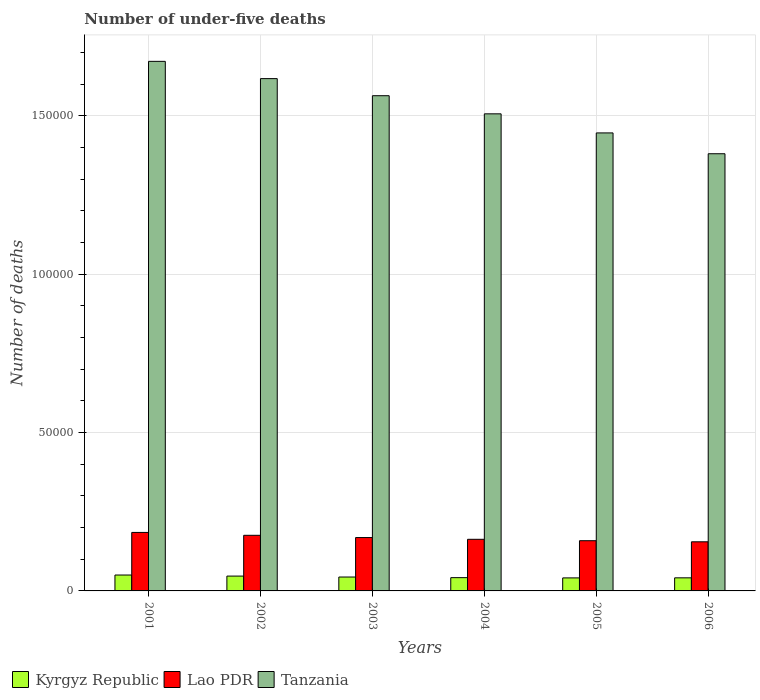How many different coloured bars are there?
Offer a very short reply. 3. Are the number of bars per tick equal to the number of legend labels?
Ensure brevity in your answer.  Yes. Are the number of bars on each tick of the X-axis equal?
Keep it short and to the point. Yes. How many bars are there on the 5th tick from the left?
Keep it short and to the point. 3. What is the number of under-five deaths in Kyrgyz Republic in 2001?
Provide a short and direct response. 5021. Across all years, what is the maximum number of under-five deaths in Tanzania?
Your response must be concise. 1.67e+05. Across all years, what is the minimum number of under-five deaths in Tanzania?
Give a very brief answer. 1.38e+05. In which year was the number of under-five deaths in Lao PDR maximum?
Provide a succinct answer. 2001. In which year was the number of under-five deaths in Tanzania minimum?
Keep it short and to the point. 2006. What is the total number of under-five deaths in Kyrgyz Republic in the graph?
Your response must be concise. 2.65e+04. What is the difference between the number of under-five deaths in Kyrgyz Republic in 2001 and that in 2002?
Your answer should be very brief. 336. What is the difference between the number of under-five deaths in Kyrgyz Republic in 2003 and the number of under-five deaths in Lao PDR in 2004?
Provide a succinct answer. -1.19e+04. What is the average number of under-five deaths in Kyrgyz Republic per year?
Make the answer very short. 4421.5. In the year 2002, what is the difference between the number of under-five deaths in Tanzania and number of under-five deaths in Kyrgyz Republic?
Your answer should be very brief. 1.57e+05. What is the ratio of the number of under-five deaths in Tanzania in 2001 to that in 2006?
Your answer should be compact. 1.21. Is the difference between the number of under-five deaths in Tanzania in 2005 and 2006 greater than the difference between the number of under-five deaths in Kyrgyz Republic in 2005 and 2006?
Keep it short and to the point. Yes. What is the difference between the highest and the second highest number of under-five deaths in Kyrgyz Republic?
Ensure brevity in your answer.  336. What is the difference between the highest and the lowest number of under-five deaths in Lao PDR?
Offer a very short reply. 2957. What does the 1st bar from the left in 2003 represents?
Make the answer very short. Kyrgyz Republic. What does the 2nd bar from the right in 2002 represents?
Offer a terse response. Lao PDR. Is it the case that in every year, the sum of the number of under-five deaths in Lao PDR and number of under-five deaths in Kyrgyz Republic is greater than the number of under-five deaths in Tanzania?
Your answer should be compact. No. How many bars are there?
Keep it short and to the point. 18. Are all the bars in the graph horizontal?
Make the answer very short. No. What is the difference between two consecutive major ticks on the Y-axis?
Give a very brief answer. 5.00e+04. Are the values on the major ticks of Y-axis written in scientific E-notation?
Provide a succinct answer. No. Does the graph contain grids?
Keep it short and to the point. Yes. Where does the legend appear in the graph?
Give a very brief answer. Bottom left. What is the title of the graph?
Provide a short and direct response. Number of under-five deaths. What is the label or title of the X-axis?
Your answer should be very brief. Years. What is the label or title of the Y-axis?
Ensure brevity in your answer.  Number of deaths. What is the Number of deaths in Kyrgyz Republic in 2001?
Make the answer very short. 5021. What is the Number of deaths of Lao PDR in 2001?
Make the answer very short. 1.85e+04. What is the Number of deaths in Tanzania in 2001?
Provide a succinct answer. 1.67e+05. What is the Number of deaths in Kyrgyz Republic in 2002?
Provide a short and direct response. 4685. What is the Number of deaths of Lao PDR in 2002?
Your answer should be very brief. 1.76e+04. What is the Number of deaths in Tanzania in 2002?
Your answer should be compact. 1.62e+05. What is the Number of deaths in Kyrgyz Republic in 2003?
Keep it short and to the point. 4389. What is the Number of deaths in Lao PDR in 2003?
Provide a short and direct response. 1.68e+04. What is the Number of deaths of Tanzania in 2003?
Make the answer very short. 1.56e+05. What is the Number of deaths in Kyrgyz Republic in 2004?
Your answer should be compact. 4189. What is the Number of deaths in Lao PDR in 2004?
Give a very brief answer. 1.63e+04. What is the Number of deaths in Tanzania in 2004?
Make the answer very short. 1.51e+05. What is the Number of deaths of Kyrgyz Republic in 2005?
Keep it short and to the point. 4113. What is the Number of deaths in Lao PDR in 2005?
Keep it short and to the point. 1.59e+04. What is the Number of deaths of Tanzania in 2005?
Ensure brevity in your answer.  1.45e+05. What is the Number of deaths in Kyrgyz Republic in 2006?
Offer a very short reply. 4132. What is the Number of deaths in Lao PDR in 2006?
Your answer should be compact. 1.55e+04. What is the Number of deaths of Tanzania in 2006?
Your answer should be very brief. 1.38e+05. Across all years, what is the maximum Number of deaths in Kyrgyz Republic?
Your response must be concise. 5021. Across all years, what is the maximum Number of deaths of Lao PDR?
Provide a succinct answer. 1.85e+04. Across all years, what is the maximum Number of deaths in Tanzania?
Your answer should be compact. 1.67e+05. Across all years, what is the minimum Number of deaths of Kyrgyz Republic?
Your answer should be compact. 4113. Across all years, what is the minimum Number of deaths of Lao PDR?
Keep it short and to the point. 1.55e+04. Across all years, what is the minimum Number of deaths of Tanzania?
Offer a terse response. 1.38e+05. What is the total Number of deaths of Kyrgyz Republic in the graph?
Your answer should be compact. 2.65e+04. What is the total Number of deaths of Lao PDR in the graph?
Keep it short and to the point. 1.01e+05. What is the total Number of deaths in Tanzania in the graph?
Provide a short and direct response. 9.19e+05. What is the difference between the Number of deaths in Kyrgyz Republic in 2001 and that in 2002?
Offer a terse response. 336. What is the difference between the Number of deaths of Lao PDR in 2001 and that in 2002?
Your answer should be compact. 907. What is the difference between the Number of deaths in Tanzania in 2001 and that in 2002?
Your answer should be compact. 5450. What is the difference between the Number of deaths in Kyrgyz Republic in 2001 and that in 2003?
Offer a terse response. 632. What is the difference between the Number of deaths in Lao PDR in 2001 and that in 2003?
Your answer should be very brief. 1617. What is the difference between the Number of deaths in Tanzania in 2001 and that in 2003?
Keep it short and to the point. 1.08e+04. What is the difference between the Number of deaths in Kyrgyz Republic in 2001 and that in 2004?
Keep it short and to the point. 832. What is the difference between the Number of deaths in Lao PDR in 2001 and that in 2004?
Your answer should be compact. 2172. What is the difference between the Number of deaths of Tanzania in 2001 and that in 2004?
Give a very brief answer. 1.66e+04. What is the difference between the Number of deaths of Kyrgyz Republic in 2001 and that in 2005?
Your response must be concise. 908. What is the difference between the Number of deaths in Lao PDR in 2001 and that in 2005?
Your answer should be compact. 2614. What is the difference between the Number of deaths of Tanzania in 2001 and that in 2005?
Give a very brief answer. 2.26e+04. What is the difference between the Number of deaths of Kyrgyz Republic in 2001 and that in 2006?
Give a very brief answer. 889. What is the difference between the Number of deaths of Lao PDR in 2001 and that in 2006?
Offer a very short reply. 2957. What is the difference between the Number of deaths in Tanzania in 2001 and that in 2006?
Ensure brevity in your answer.  2.92e+04. What is the difference between the Number of deaths in Kyrgyz Republic in 2002 and that in 2003?
Your answer should be compact. 296. What is the difference between the Number of deaths of Lao PDR in 2002 and that in 2003?
Offer a very short reply. 710. What is the difference between the Number of deaths in Tanzania in 2002 and that in 2003?
Offer a very short reply. 5400. What is the difference between the Number of deaths in Kyrgyz Republic in 2002 and that in 2004?
Offer a terse response. 496. What is the difference between the Number of deaths in Lao PDR in 2002 and that in 2004?
Offer a very short reply. 1265. What is the difference between the Number of deaths of Tanzania in 2002 and that in 2004?
Keep it short and to the point. 1.11e+04. What is the difference between the Number of deaths of Kyrgyz Republic in 2002 and that in 2005?
Your answer should be compact. 572. What is the difference between the Number of deaths of Lao PDR in 2002 and that in 2005?
Give a very brief answer. 1707. What is the difference between the Number of deaths in Tanzania in 2002 and that in 2005?
Offer a very short reply. 1.71e+04. What is the difference between the Number of deaths in Kyrgyz Republic in 2002 and that in 2006?
Your answer should be compact. 553. What is the difference between the Number of deaths in Lao PDR in 2002 and that in 2006?
Offer a terse response. 2050. What is the difference between the Number of deaths in Tanzania in 2002 and that in 2006?
Give a very brief answer. 2.37e+04. What is the difference between the Number of deaths in Kyrgyz Republic in 2003 and that in 2004?
Give a very brief answer. 200. What is the difference between the Number of deaths in Lao PDR in 2003 and that in 2004?
Your answer should be compact. 555. What is the difference between the Number of deaths in Tanzania in 2003 and that in 2004?
Offer a terse response. 5721. What is the difference between the Number of deaths in Kyrgyz Republic in 2003 and that in 2005?
Ensure brevity in your answer.  276. What is the difference between the Number of deaths in Lao PDR in 2003 and that in 2005?
Provide a short and direct response. 997. What is the difference between the Number of deaths in Tanzania in 2003 and that in 2005?
Keep it short and to the point. 1.17e+04. What is the difference between the Number of deaths in Kyrgyz Republic in 2003 and that in 2006?
Provide a succinct answer. 257. What is the difference between the Number of deaths in Lao PDR in 2003 and that in 2006?
Offer a terse response. 1340. What is the difference between the Number of deaths in Tanzania in 2003 and that in 2006?
Provide a succinct answer. 1.83e+04. What is the difference between the Number of deaths in Lao PDR in 2004 and that in 2005?
Provide a short and direct response. 442. What is the difference between the Number of deaths in Tanzania in 2004 and that in 2005?
Your response must be concise. 6023. What is the difference between the Number of deaths in Kyrgyz Republic in 2004 and that in 2006?
Your response must be concise. 57. What is the difference between the Number of deaths in Lao PDR in 2004 and that in 2006?
Provide a succinct answer. 785. What is the difference between the Number of deaths in Tanzania in 2004 and that in 2006?
Offer a terse response. 1.26e+04. What is the difference between the Number of deaths in Lao PDR in 2005 and that in 2006?
Provide a succinct answer. 343. What is the difference between the Number of deaths of Tanzania in 2005 and that in 2006?
Make the answer very short. 6576. What is the difference between the Number of deaths of Kyrgyz Republic in 2001 and the Number of deaths of Lao PDR in 2002?
Your answer should be very brief. -1.25e+04. What is the difference between the Number of deaths of Kyrgyz Republic in 2001 and the Number of deaths of Tanzania in 2002?
Provide a succinct answer. -1.57e+05. What is the difference between the Number of deaths of Lao PDR in 2001 and the Number of deaths of Tanzania in 2002?
Give a very brief answer. -1.43e+05. What is the difference between the Number of deaths in Kyrgyz Republic in 2001 and the Number of deaths in Lao PDR in 2003?
Ensure brevity in your answer.  -1.18e+04. What is the difference between the Number of deaths in Kyrgyz Republic in 2001 and the Number of deaths in Tanzania in 2003?
Provide a succinct answer. -1.51e+05. What is the difference between the Number of deaths of Lao PDR in 2001 and the Number of deaths of Tanzania in 2003?
Your answer should be very brief. -1.38e+05. What is the difference between the Number of deaths in Kyrgyz Republic in 2001 and the Number of deaths in Lao PDR in 2004?
Make the answer very short. -1.13e+04. What is the difference between the Number of deaths of Kyrgyz Republic in 2001 and the Number of deaths of Tanzania in 2004?
Ensure brevity in your answer.  -1.46e+05. What is the difference between the Number of deaths in Lao PDR in 2001 and the Number of deaths in Tanzania in 2004?
Ensure brevity in your answer.  -1.32e+05. What is the difference between the Number of deaths of Kyrgyz Republic in 2001 and the Number of deaths of Lao PDR in 2005?
Provide a short and direct response. -1.08e+04. What is the difference between the Number of deaths of Kyrgyz Republic in 2001 and the Number of deaths of Tanzania in 2005?
Your response must be concise. -1.40e+05. What is the difference between the Number of deaths in Lao PDR in 2001 and the Number of deaths in Tanzania in 2005?
Offer a very short reply. -1.26e+05. What is the difference between the Number of deaths of Kyrgyz Republic in 2001 and the Number of deaths of Lao PDR in 2006?
Your response must be concise. -1.05e+04. What is the difference between the Number of deaths of Kyrgyz Republic in 2001 and the Number of deaths of Tanzania in 2006?
Your response must be concise. -1.33e+05. What is the difference between the Number of deaths of Lao PDR in 2001 and the Number of deaths of Tanzania in 2006?
Provide a short and direct response. -1.20e+05. What is the difference between the Number of deaths of Kyrgyz Republic in 2002 and the Number of deaths of Lao PDR in 2003?
Make the answer very short. -1.22e+04. What is the difference between the Number of deaths of Kyrgyz Republic in 2002 and the Number of deaths of Tanzania in 2003?
Your response must be concise. -1.52e+05. What is the difference between the Number of deaths in Lao PDR in 2002 and the Number of deaths in Tanzania in 2003?
Make the answer very short. -1.39e+05. What is the difference between the Number of deaths in Kyrgyz Republic in 2002 and the Number of deaths in Lao PDR in 2004?
Provide a succinct answer. -1.16e+04. What is the difference between the Number of deaths in Kyrgyz Republic in 2002 and the Number of deaths in Tanzania in 2004?
Keep it short and to the point. -1.46e+05. What is the difference between the Number of deaths of Lao PDR in 2002 and the Number of deaths of Tanzania in 2004?
Give a very brief answer. -1.33e+05. What is the difference between the Number of deaths of Kyrgyz Republic in 2002 and the Number of deaths of Lao PDR in 2005?
Keep it short and to the point. -1.12e+04. What is the difference between the Number of deaths in Kyrgyz Republic in 2002 and the Number of deaths in Tanzania in 2005?
Provide a short and direct response. -1.40e+05. What is the difference between the Number of deaths in Lao PDR in 2002 and the Number of deaths in Tanzania in 2005?
Your response must be concise. -1.27e+05. What is the difference between the Number of deaths of Kyrgyz Republic in 2002 and the Number of deaths of Lao PDR in 2006?
Provide a short and direct response. -1.08e+04. What is the difference between the Number of deaths in Kyrgyz Republic in 2002 and the Number of deaths in Tanzania in 2006?
Give a very brief answer. -1.33e+05. What is the difference between the Number of deaths in Lao PDR in 2002 and the Number of deaths in Tanzania in 2006?
Provide a short and direct response. -1.20e+05. What is the difference between the Number of deaths of Kyrgyz Republic in 2003 and the Number of deaths of Lao PDR in 2004?
Your answer should be compact. -1.19e+04. What is the difference between the Number of deaths of Kyrgyz Republic in 2003 and the Number of deaths of Tanzania in 2004?
Your response must be concise. -1.46e+05. What is the difference between the Number of deaths in Lao PDR in 2003 and the Number of deaths in Tanzania in 2004?
Offer a terse response. -1.34e+05. What is the difference between the Number of deaths in Kyrgyz Republic in 2003 and the Number of deaths in Lao PDR in 2005?
Make the answer very short. -1.15e+04. What is the difference between the Number of deaths of Kyrgyz Republic in 2003 and the Number of deaths of Tanzania in 2005?
Give a very brief answer. -1.40e+05. What is the difference between the Number of deaths of Lao PDR in 2003 and the Number of deaths of Tanzania in 2005?
Ensure brevity in your answer.  -1.28e+05. What is the difference between the Number of deaths in Kyrgyz Republic in 2003 and the Number of deaths in Lao PDR in 2006?
Offer a very short reply. -1.11e+04. What is the difference between the Number of deaths in Kyrgyz Republic in 2003 and the Number of deaths in Tanzania in 2006?
Your response must be concise. -1.34e+05. What is the difference between the Number of deaths in Lao PDR in 2003 and the Number of deaths in Tanzania in 2006?
Offer a terse response. -1.21e+05. What is the difference between the Number of deaths of Kyrgyz Republic in 2004 and the Number of deaths of Lao PDR in 2005?
Keep it short and to the point. -1.17e+04. What is the difference between the Number of deaths of Kyrgyz Republic in 2004 and the Number of deaths of Tanzania in 2005?
Give a very brief answer. -1.40e+05. What is the difference between the Number of deaths of Lao PDR in 2004 and the Number of deaths of Tanzania in 2005?
Your answer should be compact. -1.28e+05. What is the difference between the Number of deaths in Kyrgyz Republic in 2004 and the Number of deaths in Lao PDR in 2006?
Your response must be concise. -1.13e+04. What is the difference between the Number of deaths of Kyrgyz Republic in 2004 and the Number of deaths of Tanzania in 2006?
Offer a terse response. -1.34e+05. What is the difference between the Number of deaths in Lao PDR in 2004 and the Number of deaths in Tanzania in 2006?
Offer a very short reply. -1.22e+05. What is the difference between the Number of deaths in Kyrgyz Republic in 2005 and the Number of deaths in Lao PDR in 2006?
Provide a succinct answer. -1.14e+04. What is the difference between the Number of deaths of Kyrgyz Republic in 2005 and the Number of deaths of Tanzania in 2006?
Offer a terse response. -1.34e+05. What is the difference between the Number of deaths of Lao PDR in 2005 and the Number of deaths of Tanzania in 2006?
Make the answer very short. -1.22e+05. What is the average Number of deaths of Kyrgyz Republic per year?
Your answer should be very brief. 4421.5. What is the average Number of deaths in Lao PDR per year?
Ensure brevity in your answer.  1.68e+04. What is the average Number of deaths of Tanzania per year?
Offer a very short reply. 1.53e+05. In the year 2001, what is the difference between the Number of deaths in Kyrgyz Republic and Number of deaths in Lao PDR?
Your response must be concise. -1.34e+04. In the year 2001, what is the difference between the Number of deaths of Kyrgyz Republic and Number of deaths of Tanzania?
Offer a terse response. -1.62e+05. In the year 2001, what is the difference between the Number of deaths in Lao PDR and Number of deaths in Tanzania?
Your answer should be compact. -1.49e+05. In the year 2002, what is the difference between the Number of deaths in Kyrgyz Republic and Number of deaths in Lao PDR?
Offer a terse response. -1.29e+04. In the year 2002, what is the difference between the Number of deaths of Kyrgyz Republic and Number of deaths of Tanzania?
Your answer should be compact. -1.57e+05. In the year 2002, what is the difference between the Number of deaths in Lao PDR and Number of deaths in Tanzania?
Ensure brevity in your answer.  -1.44e+05. In the year 2003, what is the difference between the Number of deaths of Kyrgyz Republic and Number of deaths of Lao PDR?
Keep it short and to the point. -1.25e+04. In the year 2003, what is the difference between the Number of deaths in Kyrgyz Republic and Number of deaths in Tanzania?
Your response must be concise. -1.52e+05. In the year 2003, what is the difference between the Number of deaths in Lao PDR and Number of deaths in Tanzania?
Your answer should be very brief. -1.40e+05. In the year 2004, what is the difference between the Number of deaths of Kyrgyz Republic and Number of deaths of Lao PDR?
Your answer should be very brief. -1.21e+04. In the year 2004, what is the difference between the Number of deaths of Kyrgyz Republic and Number of deaths of Tanzania?
Offer a very short reply. -1.46e+05. In the year 2004, what is the difference between the Number of deaths of Lao PDR and Number of deaths of Tanzania?
Make the answer very short. -1.34e+05. In the year 2005, what is the difference between the Number of deaths in Kyrgyz Republic and Number of deaths in Lao PDR?
Your answer should be very brief. -1.17e+04. In the year 2005, what is the difference between the Number of deaths of Kyrgyz Republic and Number of deaths of Tanzania?
Your response must be concise. -1.40e+05. In the year 2005, what is the difference between the Number of deaths of Lao PDR and Number of deaths of Tanzania?
Make the answer very short. -1.29e+05. In the year 2006, what is the difference between the Number of deaths in Kyrgyz Republic and Number of deaths in Lao PDR?
Make the answer very short. -1.14e+04. In the year 2006, what is the difference between the Number of deaths in Kyrgyz Republic and Number of deaths in Tanzania?
Provide a short and direct response. -1.34e+05. In the year 2006, what is the difference between the Number of deaths of Lao PDR and Number of deaths of Tanzania?
Provide a short and direct response. -1.23e+05. What is the ratio of the Number of deaths in Kyrgyz Republic in 2001 to that in 2002?
Offer a terse response. 1.07. What is the ratio of the Number of deaths of Lao PDR in 2001 to that in 2002?
Your response must be concise. 1.05. What is the ratio of the Number of deaths in Tanzania in 2001 to that in 2002?
Provide a short and direct response. 1.03. What is the ratio of the Number of deaths of Kyrgyz Republic in 2001 to that in 2003?
Keep it short and to the point. 1.14. What is the ratio of the Number of deaths in Lao PDR in 2001 to that in 2003?
Provide a short and direct response. 1.1. What is the ratio of the Number of deaths of Tanzania in 2001 to that in 2003?
Ensure brevity in your answer.  1.07. What is the ratio of the Number of deaths of Kyrgyz Republic in 2001 to that in 2004?
Offer a very short reply. 1.2. What is the ratio of the Number of deaths of Lao PDR in 2001 to that in 2004?
Give a very brief answer. 1.13. What is the ratio of the Number of deaths of Tanzania in 2001 to that in 2004?
Give a very brief answer. 1.11. What is the ratio of the Number of deaths of Kyrgyz Republic in 2001 to that in 2005?
Provide a succinct answer. 1.22. What is the ratio of the Number of deaths in Lao PDR in 2001 to that in 2005?
Ensure brevity in your answer.  1.16. What is the ratio of the Number of deaths of Tanzania in 2001 to that in 2005?
Your answer should be very brief. 1.16. What is the ratio of the Number of deaths in Kyrgyz Republic in 2001 to that in 2006?
Make the answer very short. 1.22. What is the ratio of the Number of deaths of Lao PDR in 2001 to that in 2006?
Offer a terse response. 1.19. What is the ratio of the Number of deaths in Tanzania in 2001 to that in 2006?
Give a very brief answer. 1.21. What is the ratio of the Number of deaths in Kyrgyz Republic in 2002 to that in 2003?
Ensure brevity in your answer.  1.07. What is the ratio of the Number of deaths in Lao PDR in 2002 to that in 2003?
Make the answer very short. 1.04. What is the ratio of the Number of deaths of Tanzania in 2002 to that in 2003?
Make the answer very short. 1.03. What is the ratio of the Number of deaths in Kyrgyz Republic in 2002 to that in 2004?
Provide a short and direct response. 1.12. What is the ratio of the Number of deaths in Lao PDR in 2002 to that in 2004?
Offer a very short reply. 1.08. What is the ratio of the Number of deaths of Tanzania in 2002 to that in 2004?
Ensure brevity in your answer.  1.07. What is the ratio of the Number of deaths in Kyrgyz Republic in 2002 to that in 2005?
Provide a short and direct response. 1.14. What is the ratio of the Number of deaths in Lao PDR in 2002 to that in 2005?
Offer a terse response. 1.11. What is the ratio of the Number of deaths of Tanzania in 2002 to that in 2005?
Provide a succinct answer. 1.12. What is the ratio of the Number of deaths in Kyrgyz Republic in 2002 to that in 2006?
Offer a very short reply. 1.13. What is the ratio of the Number of deaths in Lao PDR in 2002 to that in 2006?
Offer a very short reply. 1.13. What is the ratio of the Number of deaths in Tanzania in 2002 to that in 2006?
Ensure brevity in your answer.  1.17. What is the ratio of the Number of deaths in Kyrgyz Republic in 2003 to that in 2004?
Provide a succinct answer. 1.05. What is the ratio of the Number of deaths of Lao PDR in 2003 to that in 2004?
Offer a terse response. 1.03. What is the ratio of the Number of deaths of Tanzania in 2003 to that in 2004?
Your answer should be compact. 1.04. What is the ratio of the Number of deaths in Kyrgyz Republic in 2003 to that in 2005?
Provide a short and direct response. 1.07. What is the ratio of the Number of deaths in Lao PDR in 2003 to that in 2005?
Give a very brief answer. 1.06. What is the ratio of the Number of deaths in Tanzania in 2003 to that in 2005?
Offer a terse response. 1.08. What is the ratio of the Number of deaths of Kyrgyz Republic in 2003 to that in 2006?
Keep it short and to the point. 1.06. What is the ratio of the Number of deaths in Lao PDR in 2003 to that in 2006?
Keep it short and to the point. 1.09. What is the ratio of the Number of deaths of Tanzania in 2003 to that in 2006?
Keep it short and to the point. 1.13. What is the ratio of the Number of deaths in Kyrgyz Republic in 2004 to that in 2005?
Ensure brevity in your answer.  1.02. What is the ratio of the Number of deaths in Lao PDR in 2004 to that in 2005?
Make the answer very short. 1.03. What is the ratio of the Number of deaths of Tanzania in 2004 to that in 2005?
Your answer should be very brief. 1.04. What is the ratio of the Number of deaths in Kyrgyz Republic in 2004 to that in 2006?
Your response must be concise. 1.01. What is the ratio of the Number of deaths in Lao PDR in 2004 to that in 2006?
Provide a short and direct response. 1.05. What is the ratio of the Number of deaths of Tanzania in 2004 to that in 2006?
Your answer should be compact. 1.09. What is the ratio of the Number of deaths in Kyrgyz Republic in 2005 to that in 2006?
Provide a succinct answer. 1. What is the ratio of the Number of deaths of Lao PDR in 2005 to that in 2006?
Make the answer very short. 1.02. What is the ratio of the Number of deaths in Tanzania in 2005 to that in 2006?
Offer a terse response. 1.05. What is the difference between the highest and the second highest Number of deaths in Kyrgyz Republic?
Make the answer very short. 336. What is the difference between the highest and the second highest Number of deaths of Lao PDR?
Your answer should be compact. 907. What is the difference between the highest and the second highest Number of deaths of Tanzania?
Provide a short and direct response. 5450. What is the difference between the highest and the lowest Number of deaths of Kyrgyz Republic?
Give a very brief answer. 908. What is the difference between the highest and the lowest Number of deaths in Lao PDR?
Ensure brevity in your answer.  2957. What is the difference between the highest and the lowest Number of deaths in Tanzania?
Offer a terse response. 2.92e+04. 